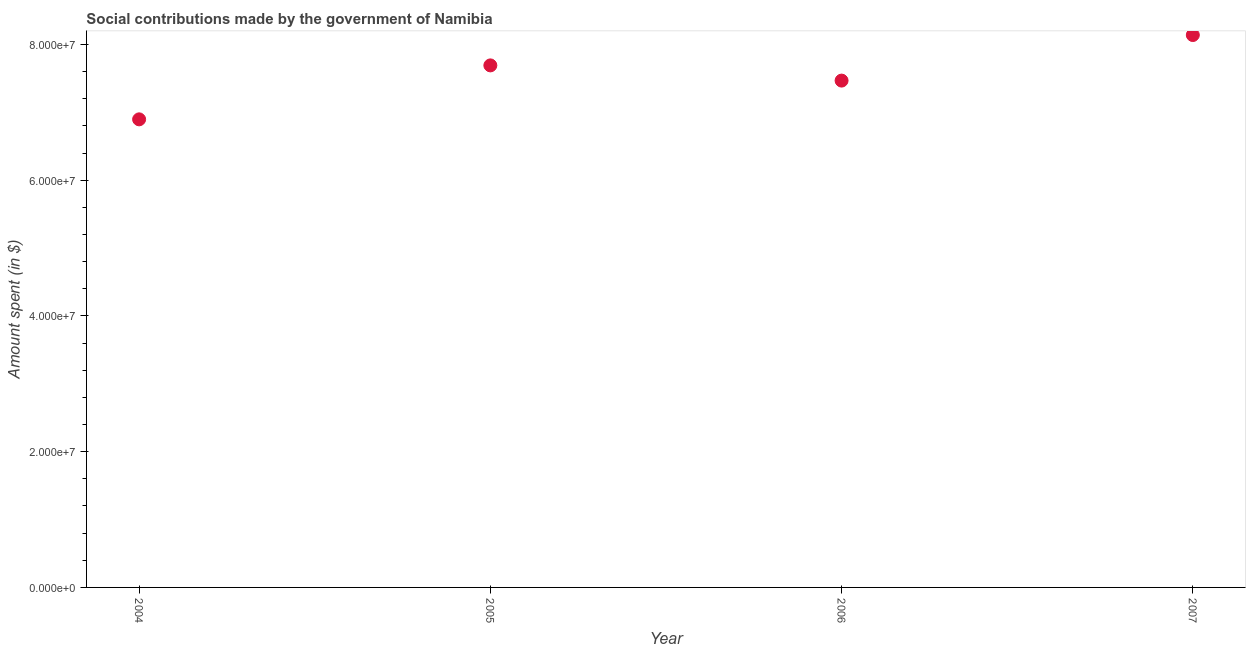What is the amount spent in making social contributions in 2007?
Your answer should be very brief. 8.14e+07. Across all years, what is the maximum amount spent in making social contributions?
Your response must be concise. 8.14e+07. Across all years, what is the minimum amount spent in making social contributions?
Ensure brevity in your answer.  6.90e+07. In which year was the amount spent in making social contributions minimum?
Offer a very short reply. 2004. What is the sum of the amount spent in making social contributions?
Make the answer very short. 3.02e+08. What is the difference between the amount spent in making social contributions in 2004 and 2006?
Ensure brevity in your answer.  -5.71e+06. What is the average amount spent in making social contributions per year?
Your answer should be very brief. 7.55e+07. What is the median amount spent in making social contributions?
Give a very brief answer. 7.58e+07. Do a majority of the years between 2006 and 2004 (inclusive) have amount spent in making social contributions greater than 72000000 $?
Your response must be concise. No. What is the ratio of the amount spent in making social contributions in 2004 to that in 2006?
Ensure brevity in your answer.  0.92. What is the difference between the highest and the second highest amount spent in making social contributions?
Offer a terse response. 4.47e+06. Is the sum of the amount spent in making social contributions in 2005 and 2006 greater than the maximum amount spent in making social contributions across all years?
Your answer should be compact. Yes. What is the difference between the highest and the lowest amount spent in making social contributions?
Keep it short and to the point. 1.24e+07. How many dotlines are there?
Your answer should be compact. 1. How many years are there in the graph?
Your response must be concise. 4. What is the difference between two consecutive major ticks on the Y-axis?
Offer a terse response. 2.00e+07. Are the values on the major ticks of Y-axis written in scientific E-notation?
Keep it short and to the point. Yes. Does the graph contain grids?
Keep it short and to the point. No. What is the title of the graph?
Your answer should be very brief. Social contributions made by the government of Namibia. What is the label or title of the X-axis?
Ensure brevity in your answer.  Year. What is the label or title of the Y-axis?
Provide a short and direct response. Amount spent (in $). What is the Amount spent (in $) in 2004?
Your response must be concise. 6.90e+07. What is the Amount spent (in $) in 2005?
Offer a very short reply. 7.69e+07. What is the Amount spent (in $) in 2006?
Make the answer very short. 7.47e+07. What is the Amount spent (in $) in 2007?
Your response must be concise. 8.14e+07. What is the difference between the Amount spent (in $) in 2004 and 2005?
Provide a succinct answer. -7.95e+06. What is the difference between the Amount spent (in $) in 2004 and 2006?
Provide a succinct answer. -5.71e+06. What is the difference between the Amount spent (in $) in 2004 and 2007?
Keep it short and to the point. -1.24e+07. What is the difference between the Amount spent (in $) in 2005 and 2006?
Give a very brief answer. 2.24e+06. What is the difference between the Amount spent (in $) in 2005 and 2007?
Give a very brief answer. -4.47e+06. What is the difference between the Amount spent (in $) in 2006 and 2007?
Your response must be concise. -6.71e+06. What is the ratio of the Amount spent (in $) in 2004 to that in 2005?
Provide a short and direct response. 0.9. What is the ratio of the Amount spent (in $) in 2004 to that in 2006?
Your response must be concise. 0.92. What is the ratio of the Amount spent (in $) in 2004 to that in 2007?
Ensure brevity in your answer.  0.85. What is the ratio of the Amount spent (in $) in 2005 to that in 2007?
Offer a terse response. 0.94. What is the ratio of the Amount spent (in $) in 2006 to that in 2007?
Provide a short and direct response. 0.92. 